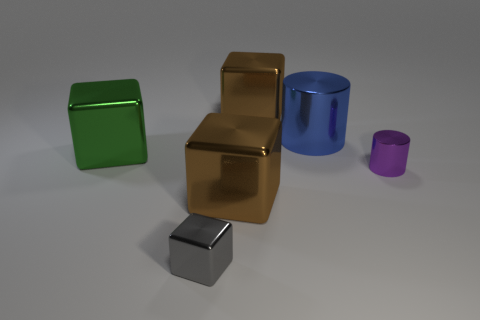Subtract all tiny blocks. How many blocks are left? 3 Add 4 brown shiny cubes. How many objects exist? 10 Subtract all blue cylinders. How many cylinders are left? 1 Subtract 1 cylinders. How many cylinders are left? 1 Subtract all yellow cylinders. Subtract all yellow balls. How many cylinders are left? 2 Subtract all gray balls. How many gray blocks are left? 1 Subtract all brown metallic things. Subtract all large blue things. How many objects are left? 3 Add 6 small metal cylinders. How many small metal cylinders are left? 7 Add 1 purple cubes. How many purple cubes exist? 1 Subtract 0 green balls. How many objects are left? 6 